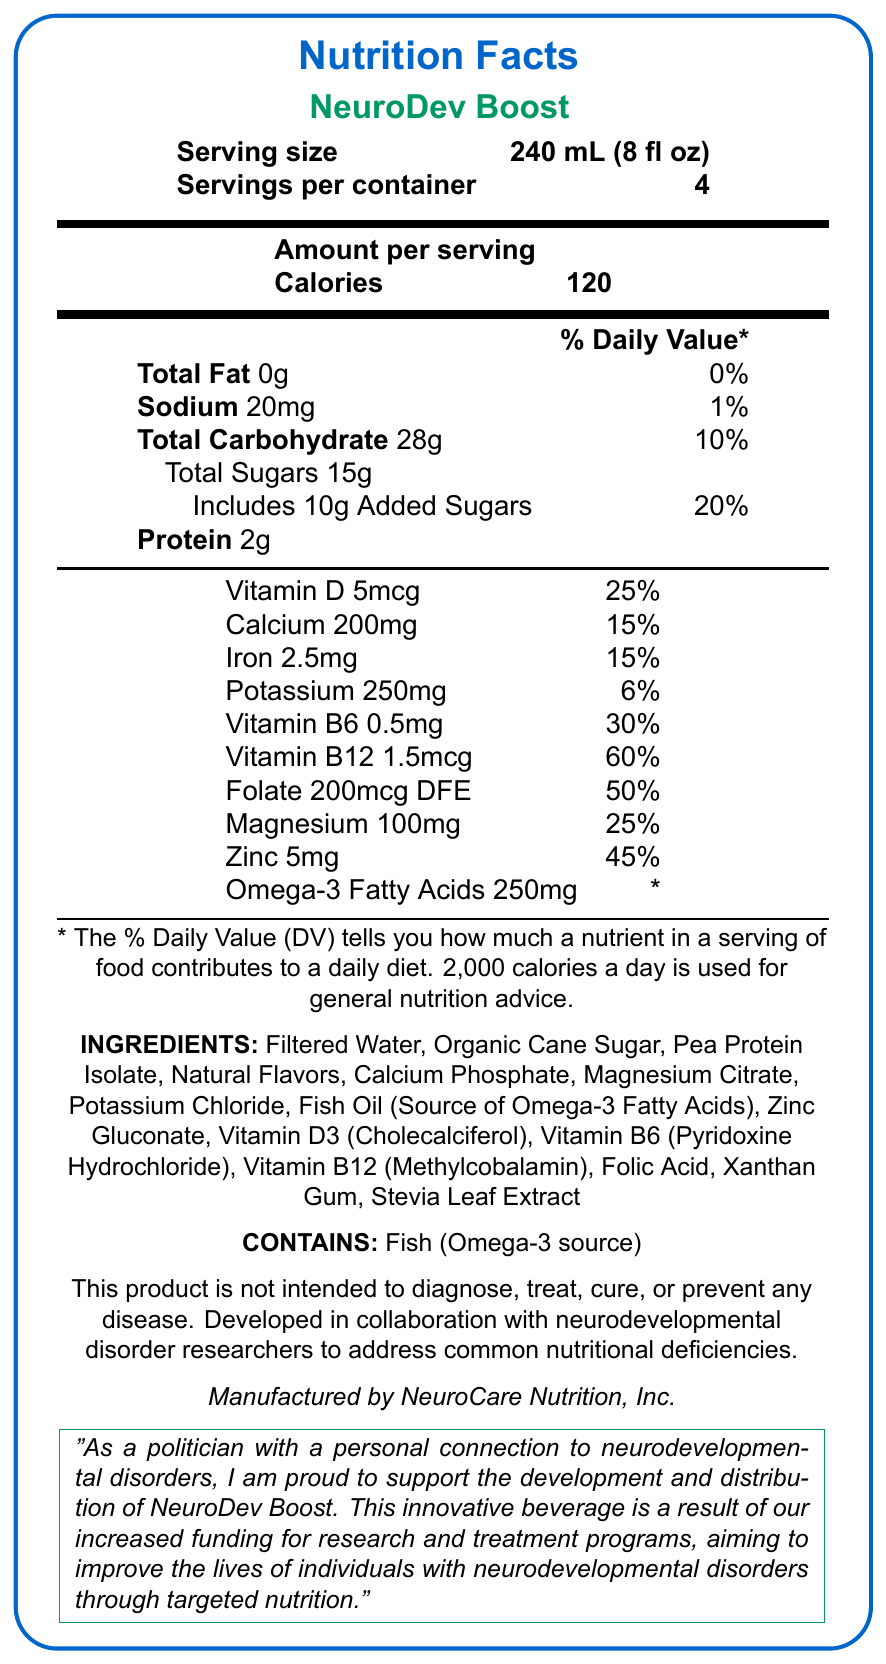what is the serving size of NeuroDev Boost? The serving size is explicitly stated in the document as "240 mL (8 fl oz)".
Answer: 240 mL (8 fl oz) how many servings are there per container? The document indicates that there are 4 servings per container.
Answer: 4 how many calories are there per serving? The nutrition facts section shows that there are 120 calories per serving.
Answer: 120 what is the amount of protein per serving? The nutrition facts section specifies that each serving contains 2g of protein.
Answer: 2g how much sodium does a serving contain? The sodium content per serving is noted as 20mg in the nutrition facts section.
Answer: 20mg what is the percentage daily value for vitamin D in NeuroDev Boost? The document indicates that one serving provides 25% of the daily value for vitamin D.
Answer: 25% name one ingredient in NeuroDev Boost that can be a source of omega-3 fatty acids The ingredients list specifically mentions Fish Oil as the source of omega-3 fatty acids.
Answer: Fish Oil which vitamin has the highest percentage daily value in this beverage? A. Vitamin D B. Vitamin B6 C. Vitamin B12 D. Folate Vitamin B12 has a daily value percentage of 60%, which is the highest among the listed vitamins.
Answer: C. Vitamin B12 what is the total sugar content per serving? A. 10g B. 15g C. 28g The total sugars per serving include 15g, as listed in the nutrition facts.
Answer: B. 15g which of the following nutrients does not have an established daily value? A. Folate B. Omega-3 Fatty Acids C. Vitamin B12 The footnote specifies that the daily value for omega-3 fatty acids is not established.
Answer: B. Omega-3 Fatty Acids does NeuroDev Boost contain any allergens? The allergen information states that the product contains fish (as the source of omega-3 fatty acids).
Answer: Yes is this product intended to diagnose, treat, cure, or prevent any disease? The disclaimer clearly states that the product is not intended to diagnose, treat, cure, or prevent any disease.
Answer: No summarize the main idea of the document The document outlines the nutritional content per serving, includes allergen information, and emphasizes the product's focus on providing targeted nutrition for neurodevelopmental disorders, with an endorsement from a politician highlighting the positive impact of increased research funding.
Answer: The document provides the nutrition facts for NeuroDev Boost, a fortified beverage aimed at addressing common nutritional deficiencies in individuals with neurodevelopmental disorders. It lists nutrients, ingredients, and contains a statement from a politician endorsing the product due to increased funding for research and treatment in neurodevelopmental disorders. how many grams of total fat are there in one serving? The document clearly states that there are 0 grams of total fat per serving.
Answer: 0g what is the daily value percentage of iron in one serving? The nutrition section indicates that each serving contains 15% of the daily value for iron.
Answer: 15% who manufactures NeuroDev Boost? The bottom of the document credits NeuroCare Nutrition, Inc. as the manufacturer.
Answer: NeuroCare Nutrition, Inc. can I find information about pricing within this document? The document does not include any details regarding the pricing of NeuroDev Boost.
Answer: Not enough information 